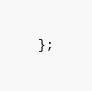<code> <loc_0><loc_0><loc_500><loc_500><_Haxe_>};
</code> 